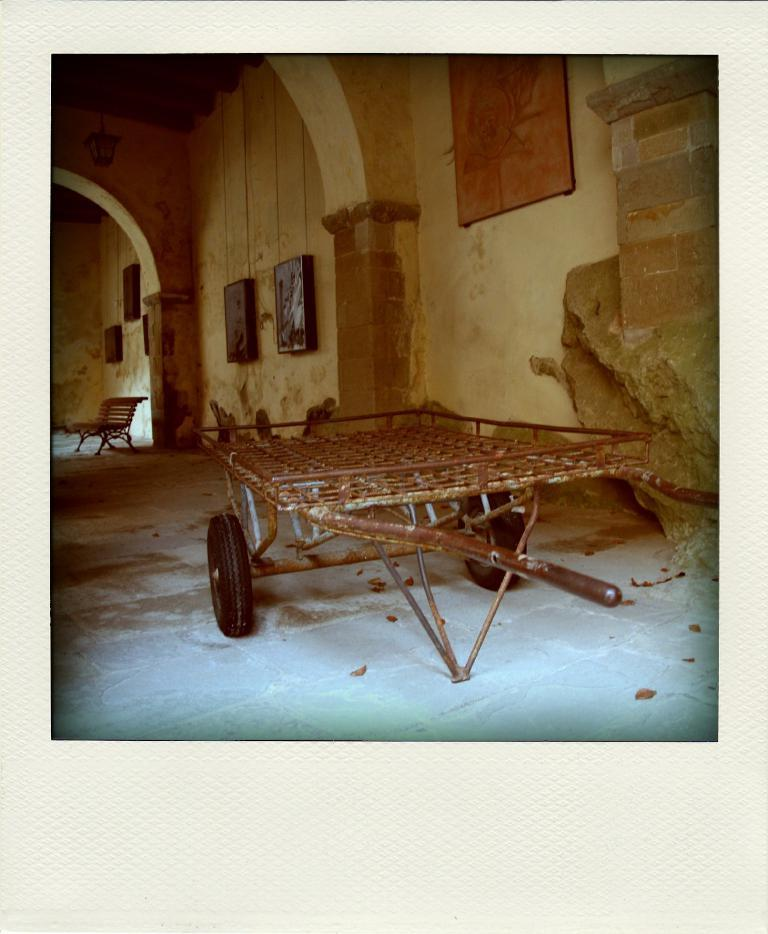What type of vehicle is in the image? There is a two-wheel trolley in the image. What type of furniture is in the image? There is a chair in the image. What type of structure is in the image? There is a wall in the image. What is on the wall in the image? There are photos on the wall. What architectural feature is visible in the image? There are arches visible in the image. What type of popcorn is being served in the image? There is no popcorn present in the image. In which direction is the trolley moving in the image? The trolley is not moving in the image; it is stationary. 